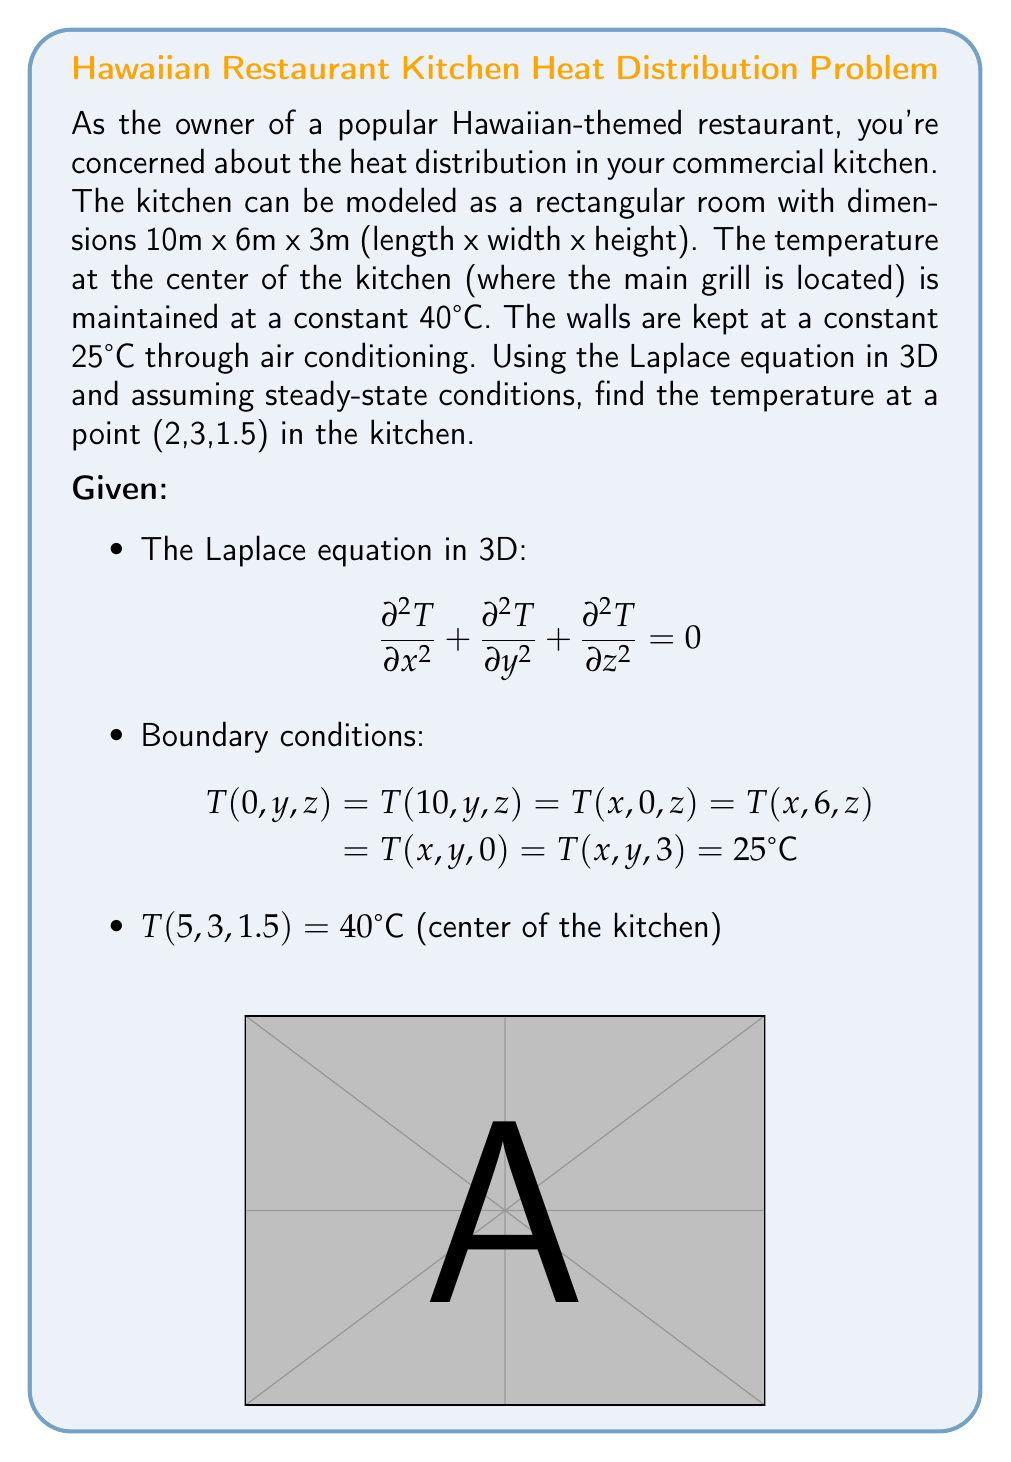Show me your answer to this math problem. To solve this problem, we'll use the method of separation of variables and apply the given boundary conditions.

1) Assume the solution has the form: $$T(x,y,z) = X(x)Y(y)Z(z)$$

2) Substituting this into the Laplace equation:

   $$\frac{X''}{X} + \frac{Y''}{Y} + \frac{Z''}{Z} = 0$$

3) This leads to three ordinary differential equations:
   
   $$X'' + \lambda^2 X = 0$$
   $$Y'' + \mu^2 Y = 0$$
   $$Z'' + \nu^2 Z = 0$$

   where $\lambda^2 + \mu^2 + \nu^2 = 0$

4) Applying the boundary conditions, we get:

   $$X(x) = A \sin(\frac{n\pi x}{10})$$
   $$Y(y) = B \sin(\frac{m\pi y}{6})$$
   $$Z(z) = C \sin(\frac{p\pi z}{3})$$

   where n, m, and p are positive integers.

5) The general solution is:

   $$T(x,y,z) = 25 + \sum_{n=1}^{\infty}\sum_{m=1}^{\infty}\sum_{p=1}^{\infty} A_{nmp} \sin(\frac{n\pi x}{10}) \sin(\frac{m\pi y}{6}) \sin(\frac{p\pi z}{3})$$

6) To find $A_{nmp}$, we use the condition at the center:

   $$40 = 25 + \sum_{n=1}^{\infty}\sum_{m=1}^{\infty}\sum_{p=1}^{\infty} A_{nmp} \sin(\frac{n\pi 5}{10}) \sin(\frac{m\pi 3}{6}) \sin(\frac{p\pi 1.5}{3})$$

7) This is a complex Fourier series. In practice, we would need to truncate the series and solve numerically for the coefficients $A_{nmp}$.

8) Once we have the coefficients, we can evaluate the temperature at (2,3,1.5) by substituting these coordinates into our solution.

In reality, solving this exactly would require advanced numerical methods. For a practical approximate solution, we could use finite difference methods or computational fluid dynamics software.
Answer: The exact analytical solution requires solving a complex Fourier series, which is beyond the scope of a simple calculation. However, we can estimate that the temperature at (2,3,1.5) would be between 25°C and 40°C, likely closer to 30°C due to its proximity to the walls. For a precise answer, numerical methods or computational fluid dynamics software would be necessary. 